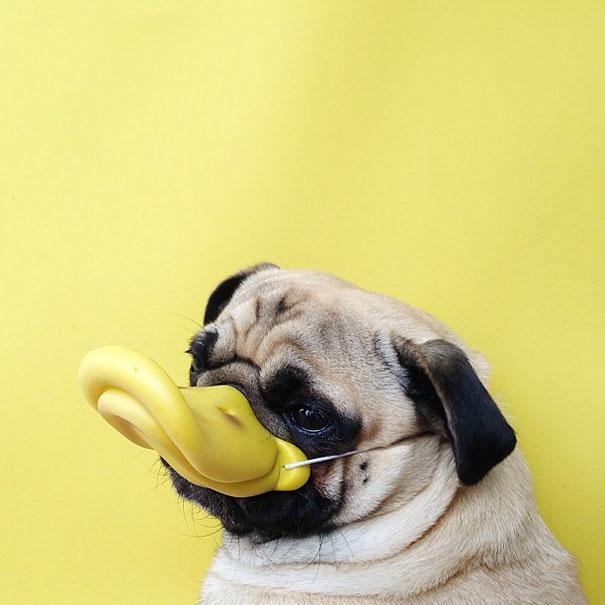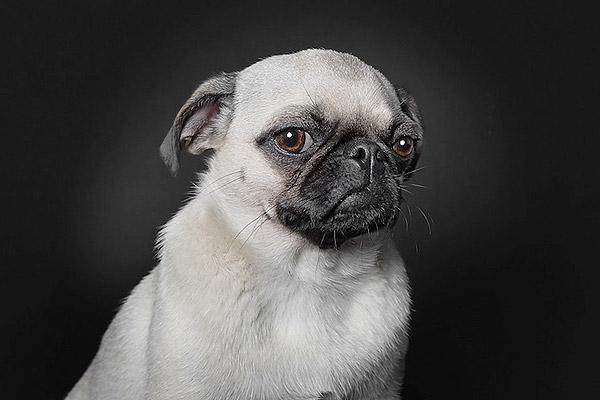The first image is the image on the left, the second image is the image on the right. For the images shown, is this caption "At least one pug is laying down." true? Answer yes or no. No. The first image is the image on the left, the second image is the image on the right. Examine the images to the left and right. Is the description "There is one pug dog facing front, and at least one pug dog with its head turned slightly to the right." accurate? Answer yes or no. No. 